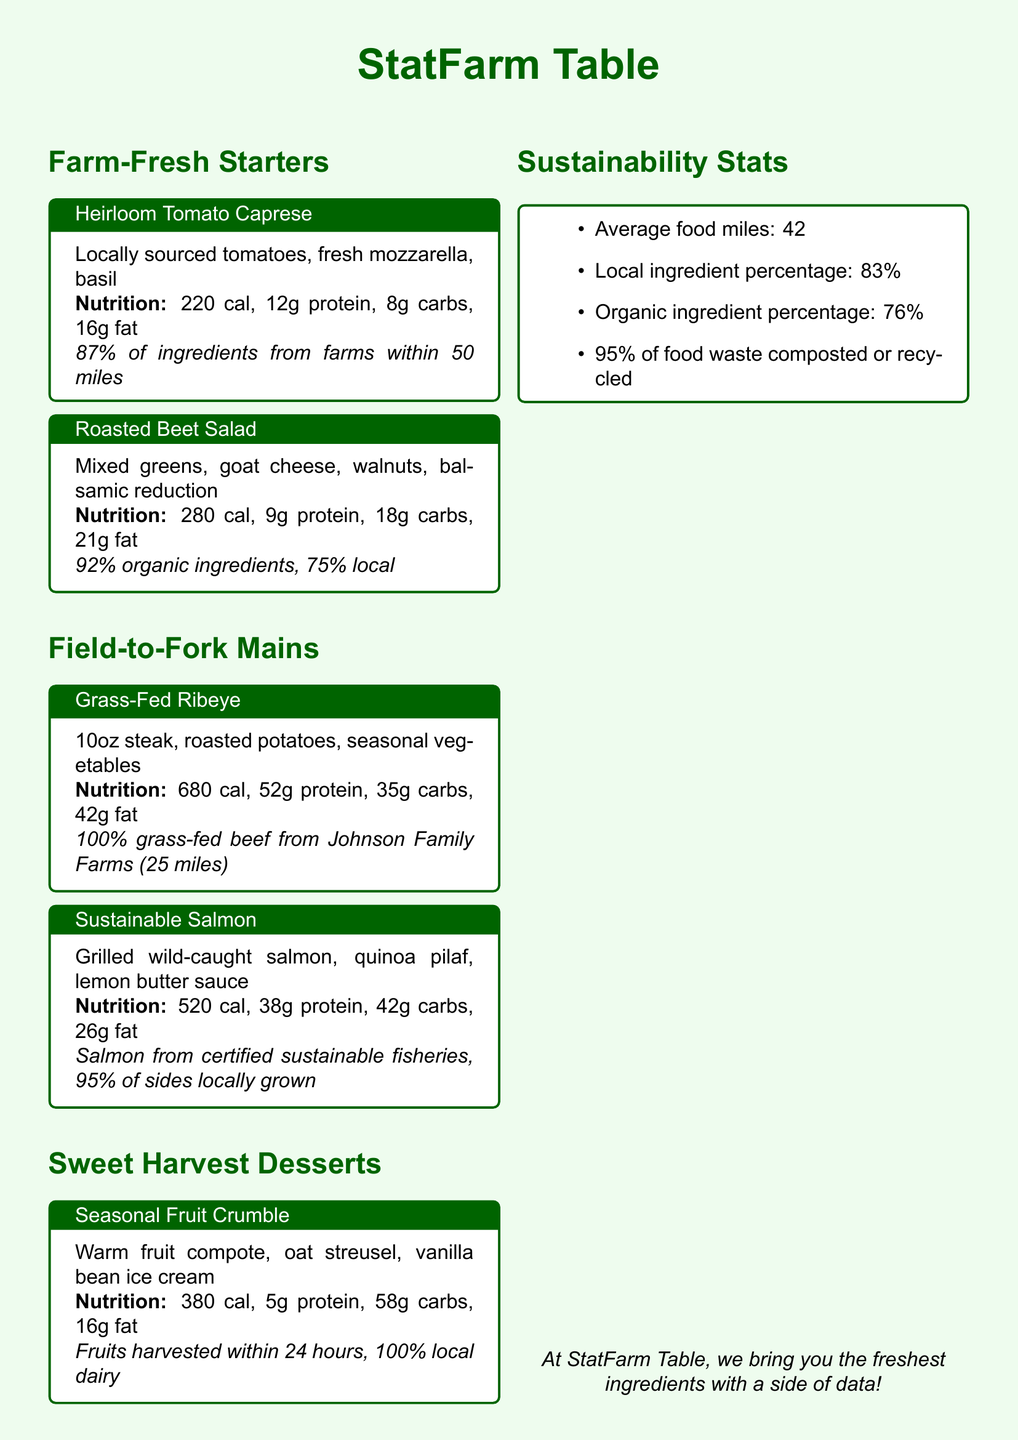what is the calorie count for the Heirloom Tomato Caprese? The calorie count for the Heirloom Tomato Caprese is listed in its nutritional information.
Answer: 220 cal what percentage of ingredients in the Roasted Beet Salad are organic? The Roasted Beet Salad states that 92% of the ingredients are organic.
Answer: 92% how many ounces is the Grass-Fed Ribeye steak? The Grass-Fed Ribeye steak is specified to be 10 ounces in the menu.
Answer: 10oz what is the protein content in the Sustainable Salmon dish? The Sustainable Salmon dish includes a specific amount of protein, which is mentioned in the nutritional information.
Answer: 38g protein what is the average food miles for the menu? The average food miles for the ingredients used in the menu is provided in the sustainability statistics section.
Answer: 42 how much of the food waste is composted or recycled? The document specifies that 95% of food waste is composted or recycled.
Answer: 95% what type of dairy is used in the Seasonal Fruit Crumble? The type of dairy used in the Seasonal Fruit Crumble is identified in the sourcing information.
Answer: 100% local dairy which farm supplies the Grass-Fed Ribeye beef? The source of the beef for the Grass-Fed Ribeye is mentioned in the description of the dish.
Answer: Johnson Family Farms 